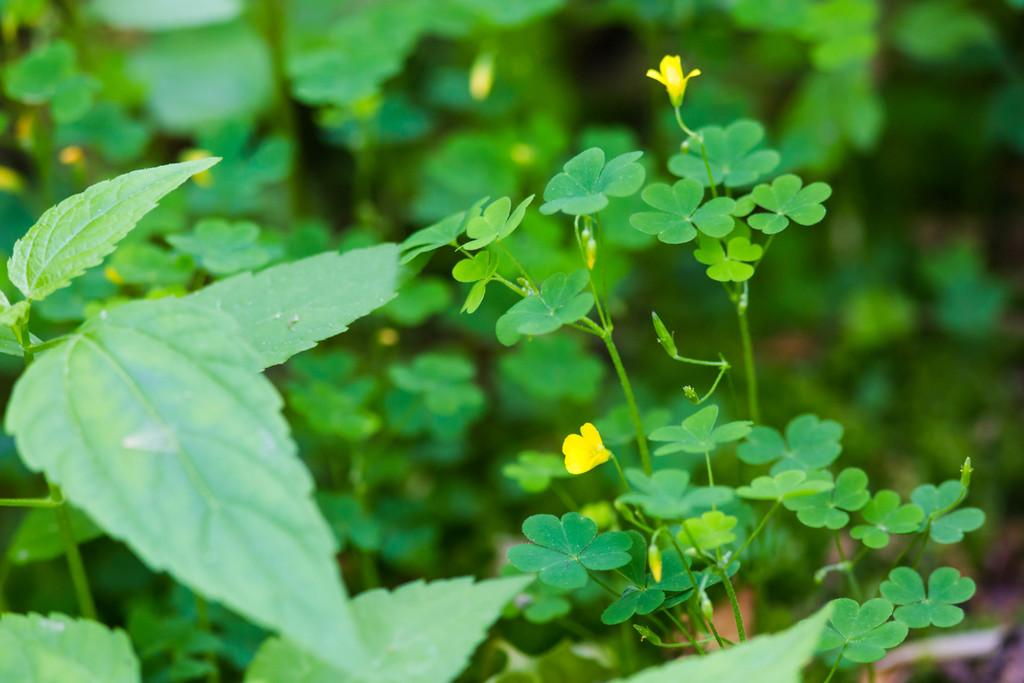What type of plant elements are visible in the image? There are leaves of plants in the image. What color are the flowers in the image? There are yellow color flowers in the image. What type of humor can be seen in the image? There is no humor present in the image; it features plants and flowers. What time of day is depicted in the image? The time of day is not visible or discernible in the image. 